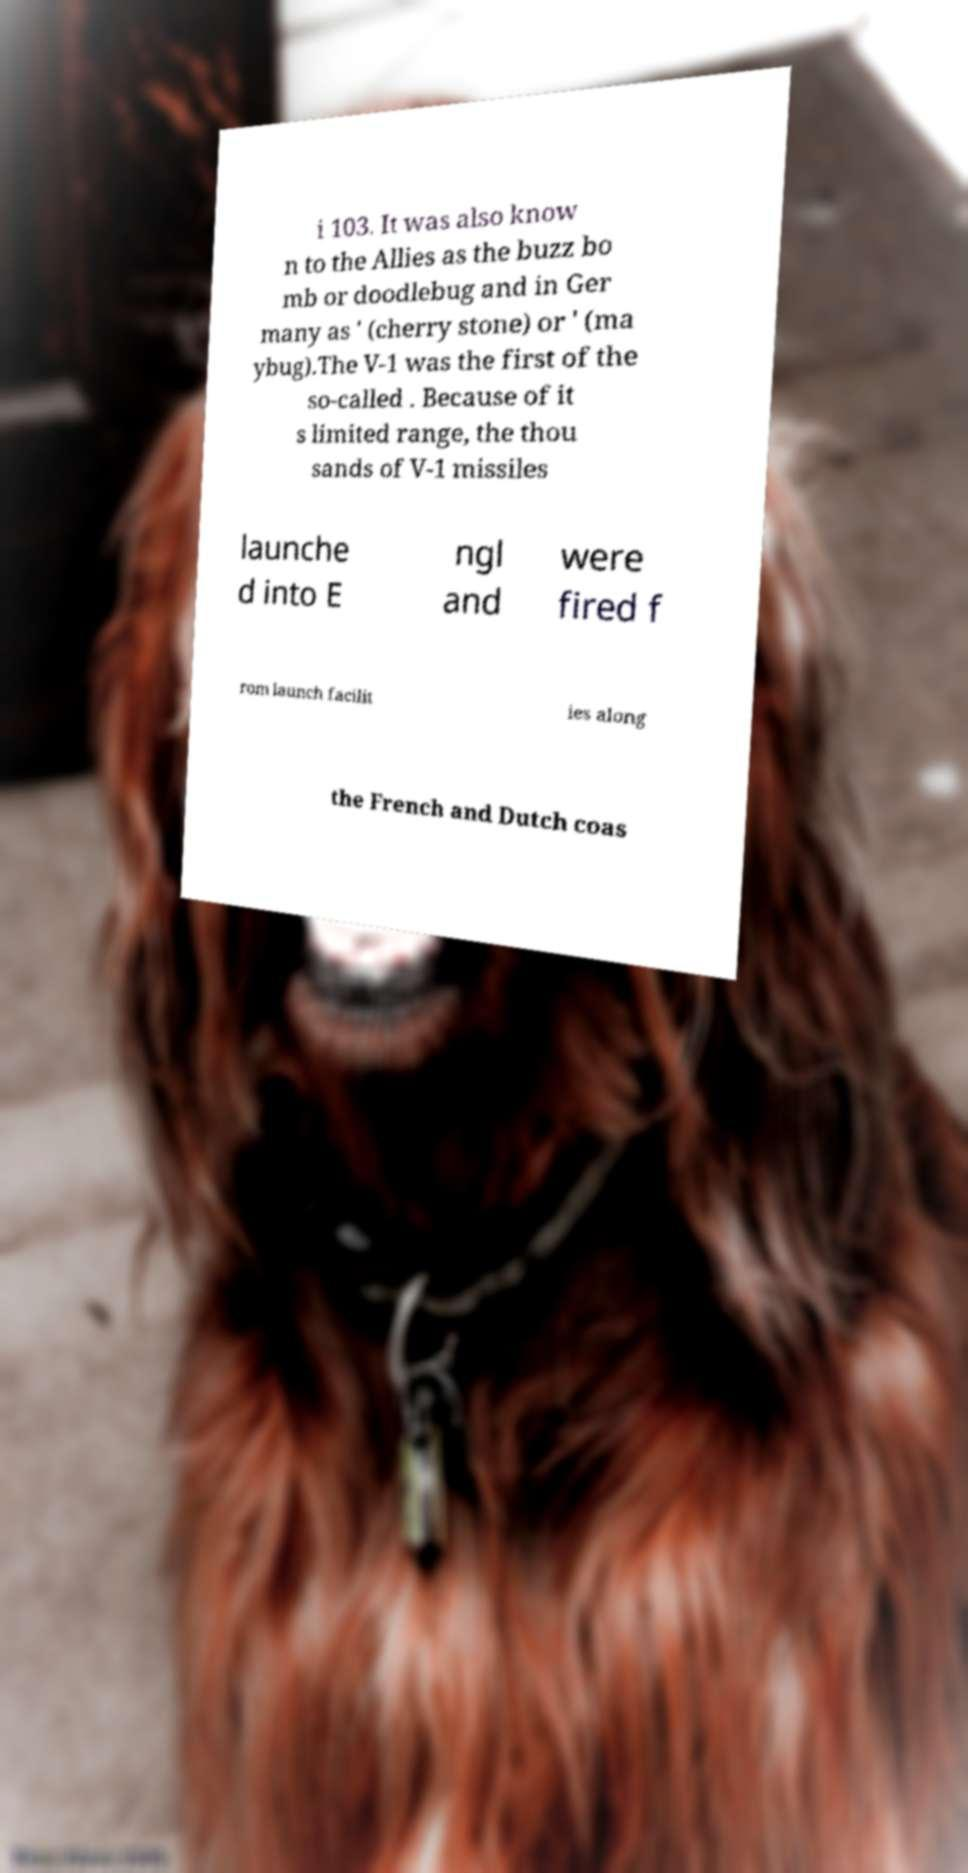For documentation purposes, I need the text within this image transcribed. Could you provide that? i 103. It was also know n to the Allies as the buzz bo mb or doodlebug and in Ger many as ' (cherry stone) or ' (ma ybug).The V-1 was the first of the so-called . Because of it s limited range, the thou sands of V-1 missiles launche d into E ngl and were fired f rom launch facilit ies along the French and Dutch coas 